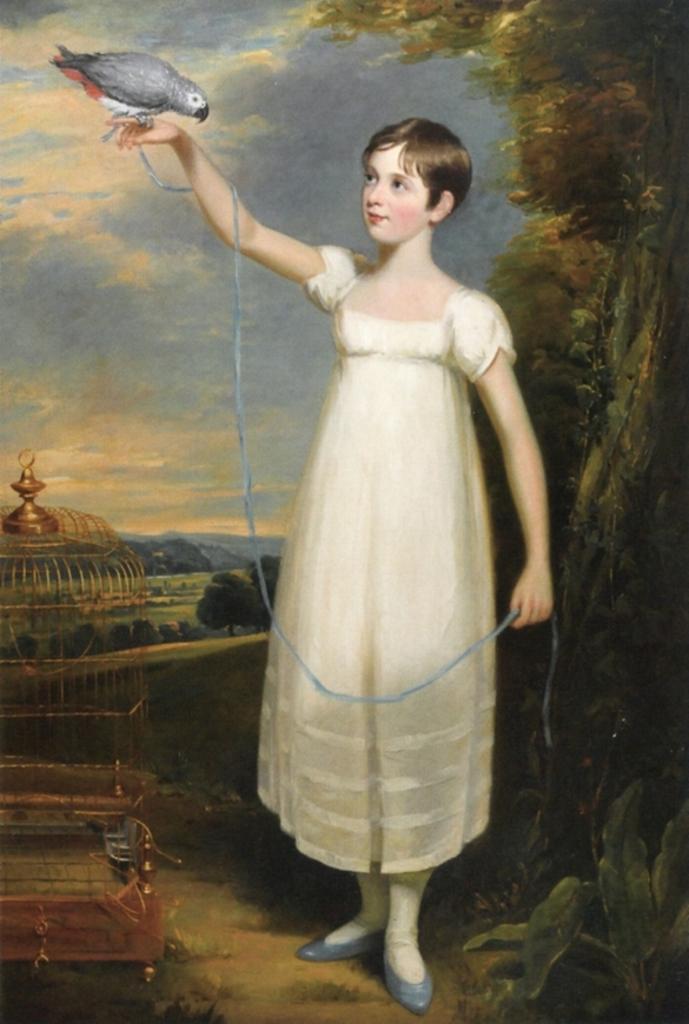Describe this image in one or two sentences. This is a painting. In which, we can see there is a girl in a white color dress, having a gray colored bird on her finger and standing on the ground. On the left side, there is a cage arranged on the ground. On the right side, there are plants and trees. In the background, there are mountains, trees and plants on the ground and there are clouds in the sky. 